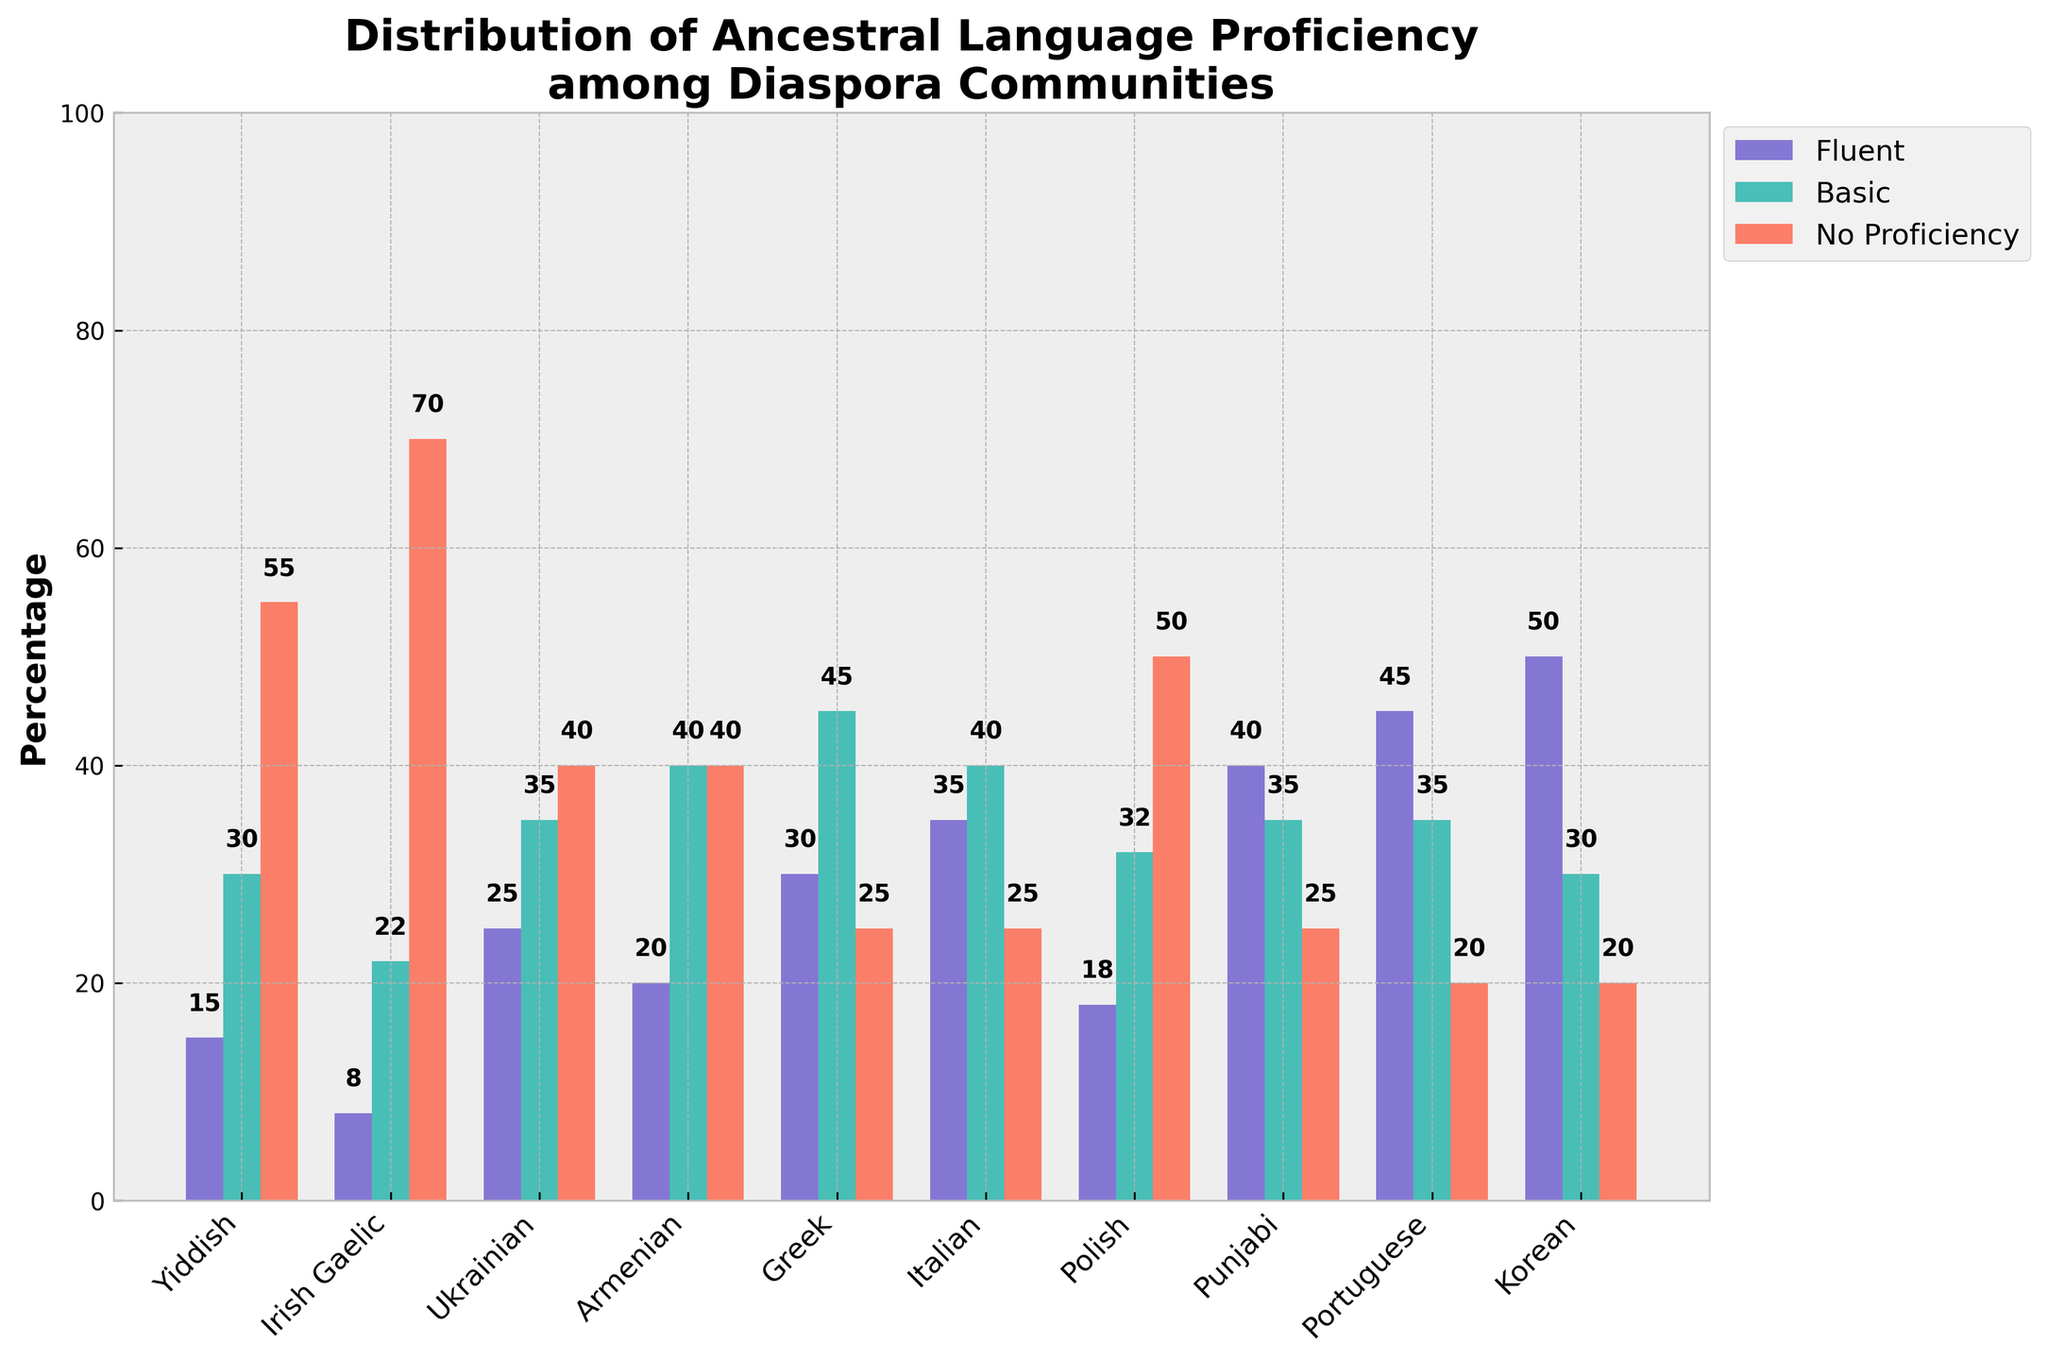Which language has the highest percentage of fluent speakers? The highest bar in the "Fluent" (blue) category corresponds to the Korean language.
Answer: Korean What is the combined percentage of fluent and basic speakers for Italian? The fluent speakers for Italian are 35%, and basic speakers are 40%. The combined percentage is 35 + 40 = 75%.
Answer: 75% Which language has the least percentage of basic speakers? Irish Gaelic has the lowest bar in the "Basic" (green) category with 22%.
Answer: Irish Gaelic Are there more fluent speakers in Punjabi or Ukrainian? The bar for Punjabi in the "Fluent" (blue) category is higher than that for Ukrainian. Punjabi has 40%, and Ukrainian has 25%.
Answer: Punjabi How does the percentage of no proficiency in Greek compare to that in Portuguese? Greek has a "No Proficiency" (red) bar at 25%, while Portuguese has 20%. Therefore, Greek is higher.
Answer: Greek What is the average percentage of fluent speakers for Greek, Italian, and Korean? Greek has 30%, Italian has 35%, and Korean has 50%. The average is (30 + 35 + 50) / 3 = 38.33%.
Answer: 38.33% Which language has the smallest percentage difference between basic and no proficiency speakers? Armenian and Greek both have a 5% difference between Basic (Armenian 40%, Greek 45%) and No Proficiency (Armenian 40%, Greek 25%).
Answer: Greek What is the total percentage (fluent + basic + no proficiency) for Yiddish? Fluent is 15%, Basic is 30%, and No Proficiency is 55%. The total percentage is 15 + 30 + 55 = 100%.
Answer: 100% Which languages have an equal percentage of fluent and no proficiency speakers? Armenian has equal percentages for fluent speakers (20%) and no proficiency speakers (40%).
Answer: Armenian How does the number of fluent speakers in Polish compare to those in Armenian? Polish has 18% fluent speakers, and Armenian has 20%; Armenian is higher.
Answer: Armenian 